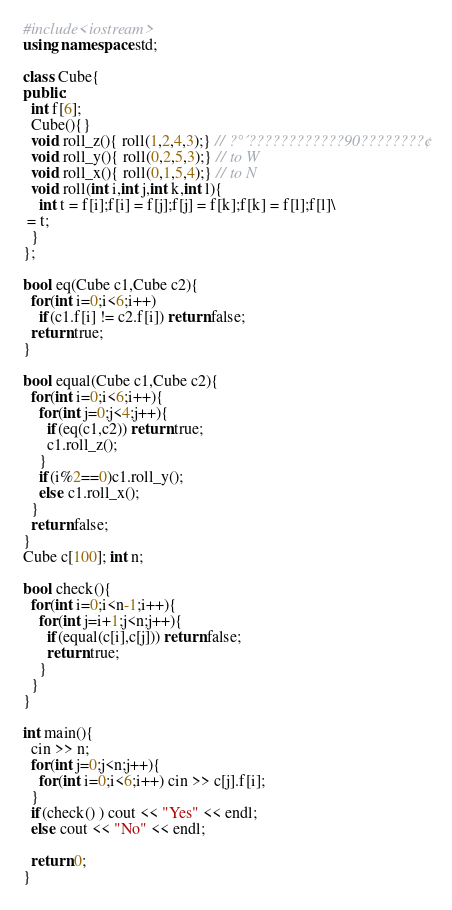<code> <loc_0><loc_0><loc_500><loc_500><_C++_>#include<iostream>                                        
using namespace std;                                      
                                                          
class Cube{                                               
public:                                                   
  int f[6];                                               
  Cube(){}                                                
  void roll_z(){ roll(1,2,4,3);} // ?°´????????????90????????¢    
  void roll_y(){ roll(0,2,5,3);} // to W                  
  void roll_x(){ roll(0,1,5,4);} // to N                  
  void roll(int i,int j,int k,int l){                     
    int t = f[i];f[i] = f[j];f[j] = f[k];f[k] = f[l];f[l]\
 = t;                                                     
  }                                                       
};                                                        
                                                          
bool eq(Cube c1,Cube c2){                                 
  for(int i=0;i<6;i++)                                    
    if(c1.f[i] != c2.f[i]) return false;                  
  return true;                                            
}                                                         
                                                          
bool equal(Cube c1,Cube c2){                              
  for(int i=0;i<6;i++){                                   
    for(int j=0;j<4;j++){                                 
      if(eq(c1,c2)) return true;                          
      c1.roll_z();                                        
    }                                                     
    if(i%2==0)c1.roll_y();                                
    else c1.roll_x();                                     
  }                                                       
  return false;                                           
}          
Cube c[100]; int n;                                       
                                                          
bool check(){                                             
  for(int i=0;i<n-1;i++){                                 
    for(int j=i+1;j<n;j++){                               
      if(equal(c[i],c[j])) return false;                  
      return true;                                        
    }                                                     
  }                                                       
}                                                         
                                                          
int main(){                                               
  cin >> n;                                               
  for(int j=0;j<n;j++){                                   
    for(int i=0;i<6;i++) cin >> c[j].f[i];                
  }                                                       
  if(check() ) cout << "Yes" << endl;                     
  else cout << "No" << endl;                              
                                                          
  return 0;                                               
}  </code> 